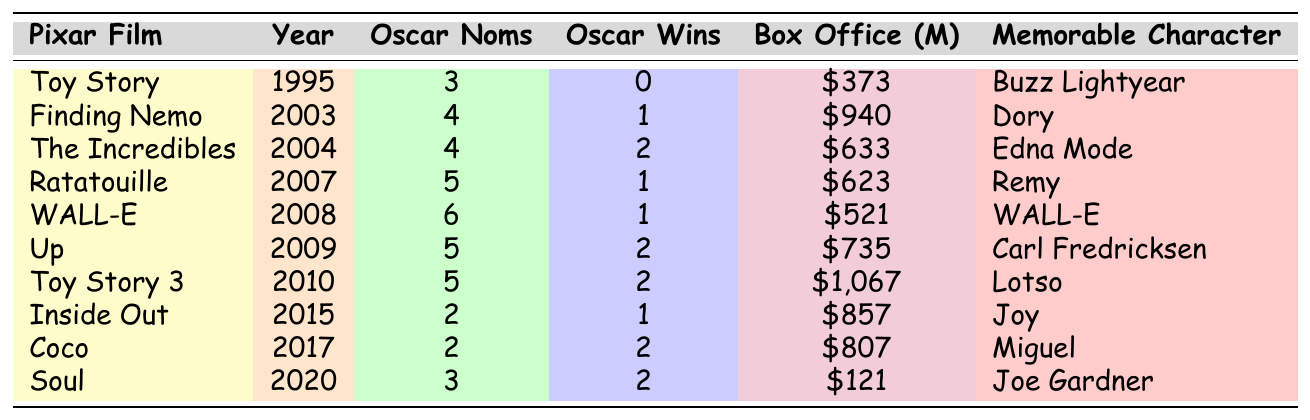Which Pixar film received the most Oscar nominations? Looking at the table, "WALL-E" has the highest number of nominations with 6.
Answer: "WALL-E" How many Oscar wins did "Finding Nemo" have? The table shows that "Finding Nemo" had 1 Oscar win.
Answer: 1 What was the box office revenue for "Toy Story 3"? Referring to the table, "Toy Story 3" earned $1,067 million at the box office.
Answer: $1,067 million Did "Soul" win more Oscars than "Coco"? Checking the table, both "Soul" and "Coco" won 2 Oscars each, so the statement is false.
Answer: No What is the difference in the number of Oscar nominations between "Up" and "Inside Out"? "Up" has 5 nominations and "Inside Out" has 2 nominations, so the difference is 5 - 2 = 3.
Answer: 3 Which character is associated with the "Ratatouille" film? According to the table, "Ratatouille" features Remy as the memorable character.
Answer: Remy What is the average box office revenue of the two films that won the most Oscars? The films that won the most Oscars, "The Incredibles", "Toy Story 3", "Up", "Coco", and "Soul" (2 Oscars each) have box office earnings of $633, $1,067, $735, $807, and $121 million, respectively. Summing these gives $3,363 million, and with 5 films, the average is $3,363 / 5 = $672.6 million.
Answer: $672.6 million Which Pixar film has the character "Dory" and how many Oscar nominations did it receive? The film "Finding Nemo" features the character "Dory" and received 4 Oscar nominations according to the table.
Answer: "Finding Nemo", 4 nominations How many films won more than 1 Oscar? In the table, the films that won more than 1 Oscar are "The Incredibles", "Up", "Toy Story 3", "Coco", and "Soul", totaling 5 films.
Answer: 5 Which film has the least box office earnings? Referring to the table, "Soul" has the least box office earnings at $121 million.
Answer: "Soul" 